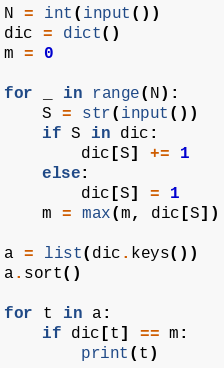Convert code to text. <code><loc_0><loc_0><loc_500><loc_500><_Python_>N = int(input())
dic = dict()
m = 0

for _ in range(N):
	S = str(input())
	if S in dic:
		dic[S] += 1
	else:
		dic[S] = 1
	m = max(m, dic[S])
		
a = list(dic.keys())
a.sort()

for t in a:
	if dic[t] == m:
		print(t)</code> 